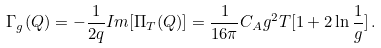<formula> <loc_0><loc_0><loc_500><loc_500>\Gamma _ { g } ( Q ) = - \frac { 1 } { 2 q } I m [ \Pi _ { T } ( Q ) ] = \frac { 1 } { 1 6 \pi } C _ { A } g ^ { 2 } T [ 1 + 2 \ln \frac { 1 } { g } ] \, .</formula> 